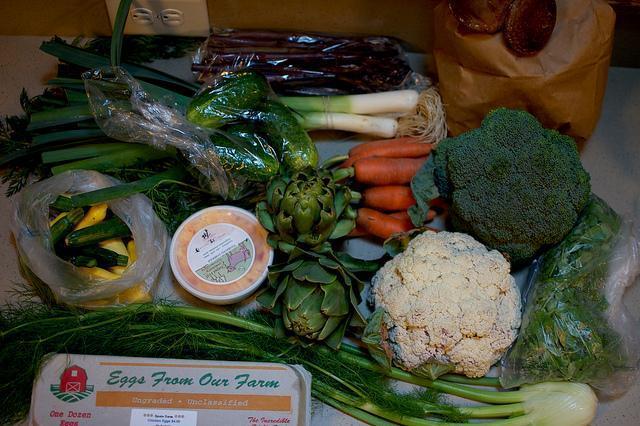How many people are in the picture?
Give a very brief answer. 0. 